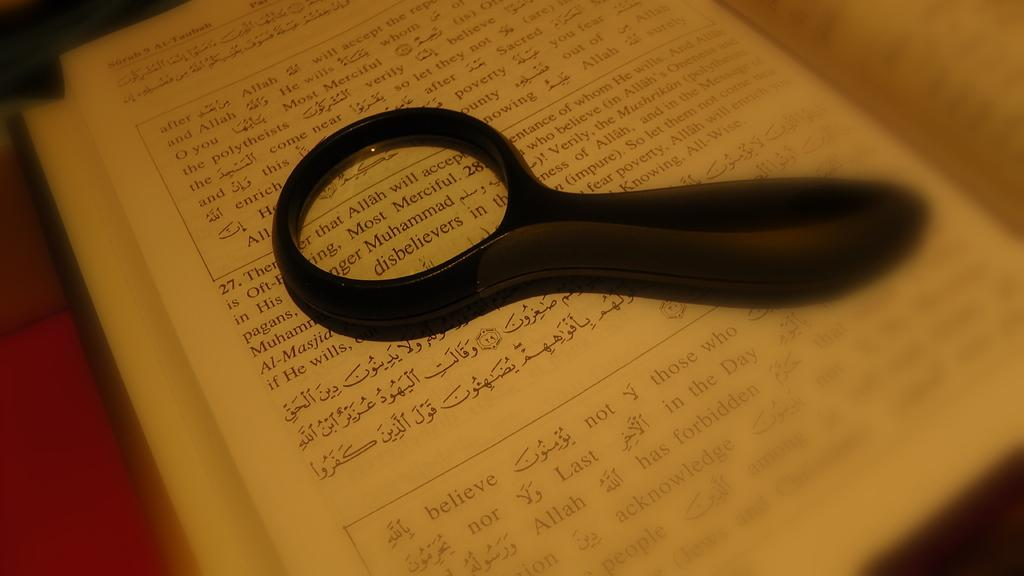Provide a one-sentence caption for the provided image. A magnifying glass shows the word disbelievers on a page. 